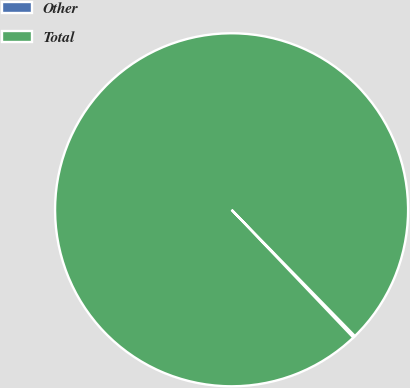Convert chart. <chart><loc_0><loc_0><loc_500><loc_500><pie_chart><fcel>Other<fcel>Total<nl><fcel>0.2%<fcel>99.8%<nl></chart> 